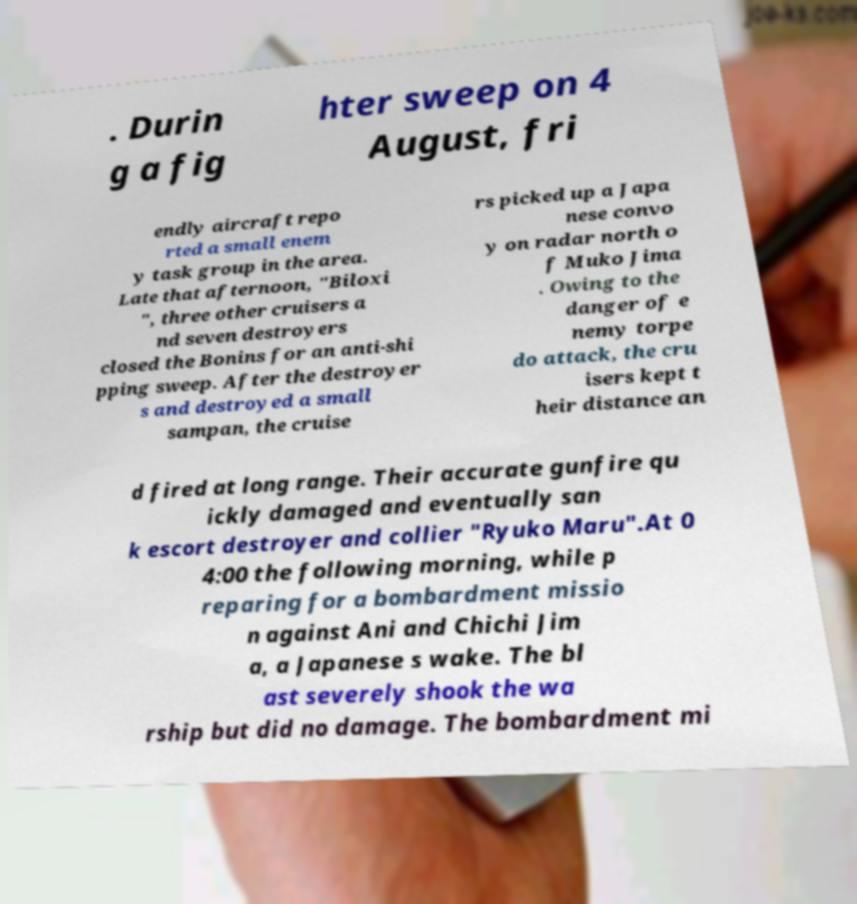For documentation purposes, I need the text within this image transcribed. Could you provide that? . Durin g a fig hter sweep on 4 August, fri endly aircraft repo rted a small enem y task group in the area. Late that afternoon, "Biloxi ", three other cruisers a nd seven destroyers closed the Bonins for an anti-shi pping sweep. After the destroyer s and destroyed a small sampan, the cruise rs picked up a Japa nese convo y on radar north o f Muko Jima . Owing to the danger of e nemy torpe do attack, the cru isers kept t heir distance an d fired at long range. Their accurate gunfire qu ickly damaged and eventually san k escort destroyer and collier "Ryuko Maru".At 0 4:00 the following morning, while p reparing for a bombardment missio n against Ani and Chichi Jim a, a Japanese s wake. The bl ast severely shook the wa rship but did no damage. The bombardment mi 